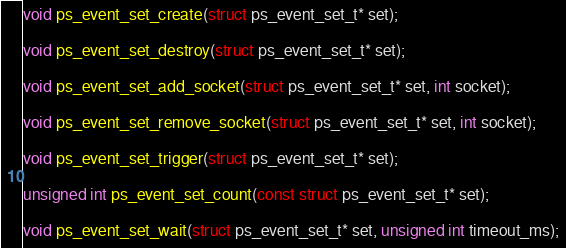<code> <loc_0><loc_0><loc_500><loc_500><_C_>
void ps_event_set_create(struct ps_event_set_t* set);

void ps_event_set_destroy(struct ps_event_set_t* set);

void ps_event_set_add_socket(struct ps_event_set_t* set, int socket);

void ps_event_set_remove_socket(struct ps_event_set_t* set, int socket);

void ps_event_set_trigger(struct ps_event_set_t* set);

unsigned int ps_event_set_count(const struct ps_event_set_t* set);

void ps_event_set_wait(struct ps_event_set_t* set, unsigned int timeout_ms);
</code> 